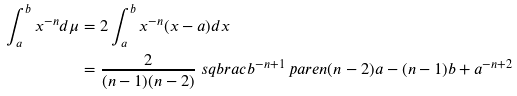Convert formula to latex. <formula><loc_0><loc_0><loc_500><loc_500>\int _ { a } ^ { b } x ^ { - n } d \mu & = 2 \int _ { a } ^ { b } x ^ { - n } ( x - a ) d x \\ & = \frac { 2 } { ( n - 1 ) ( n - 2 ) } \ s q b r a c { b ^ { - n + 1 } \ p a r e n { ( n - 2 ) a - ( n - 1 ) b } + a ^ { - n + 2 } }</formula> 